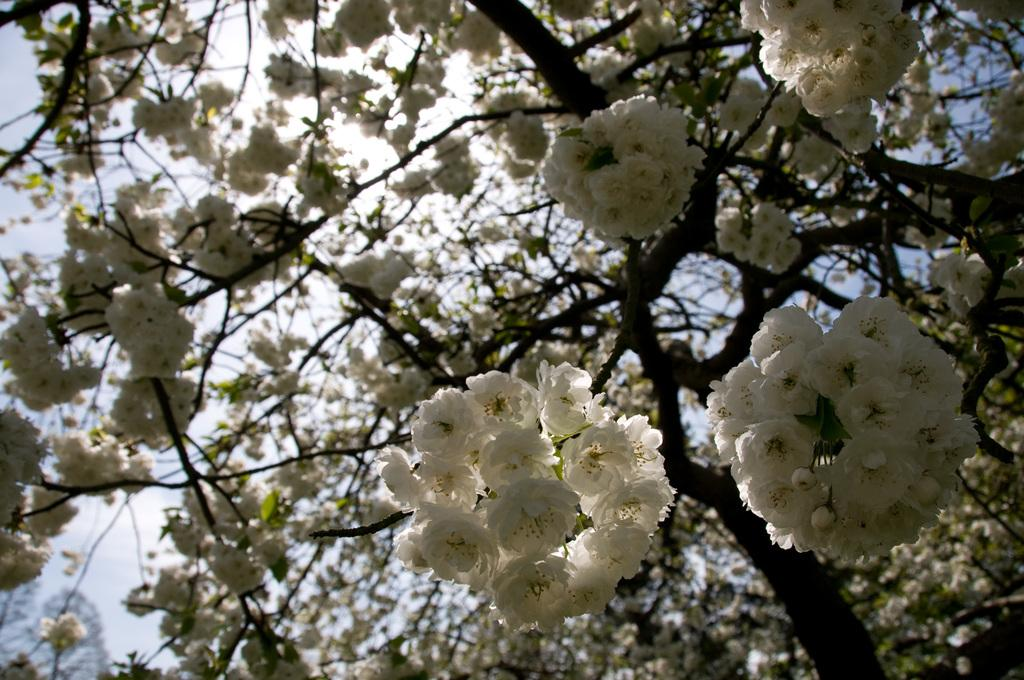What is the main subject of the image? The main subject of the image is a tree. What can be observed about the tree in the image? The tree has flowers. Where is the tree located in the image? The tree is located in the center of the image. What type of advertisement can be seen on the tree in the image? There is no advertisement present on the tree in the image; it is a tree with flowers. Can you describe the boy sitting under the tree in the image? There is no boy present in the image; it only features a tree with flowers. 